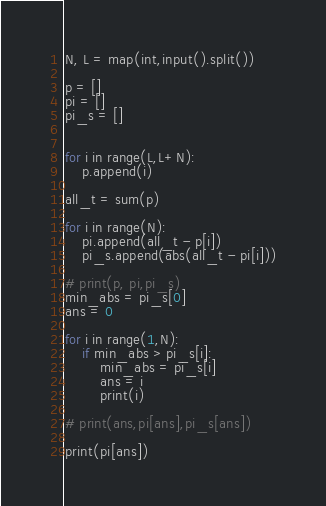<code> <loc_0><loc_0><loc_500><loc_500><_Python_>N, L = map(int,input().split())

p = []
pi = []
pi_s = []


for i in range(L,L+N):
    p.append(i)

all_t = sum(p)

for i in range(N):
    pi.append(all_t - p[i])
    pi_s.append(abs(all_t - pi[i]))

# print(p, pi,pi_s)
min_abs = pi_s[0]
ans = 0

for i in range(1,N):
    if min_abs > pi_s[i]:
        min_abs = pi_s[i]
        ans = i
        print(i)

# print(ans,pi[ans],pi_s[ans])

print(pi[ans])</code> 